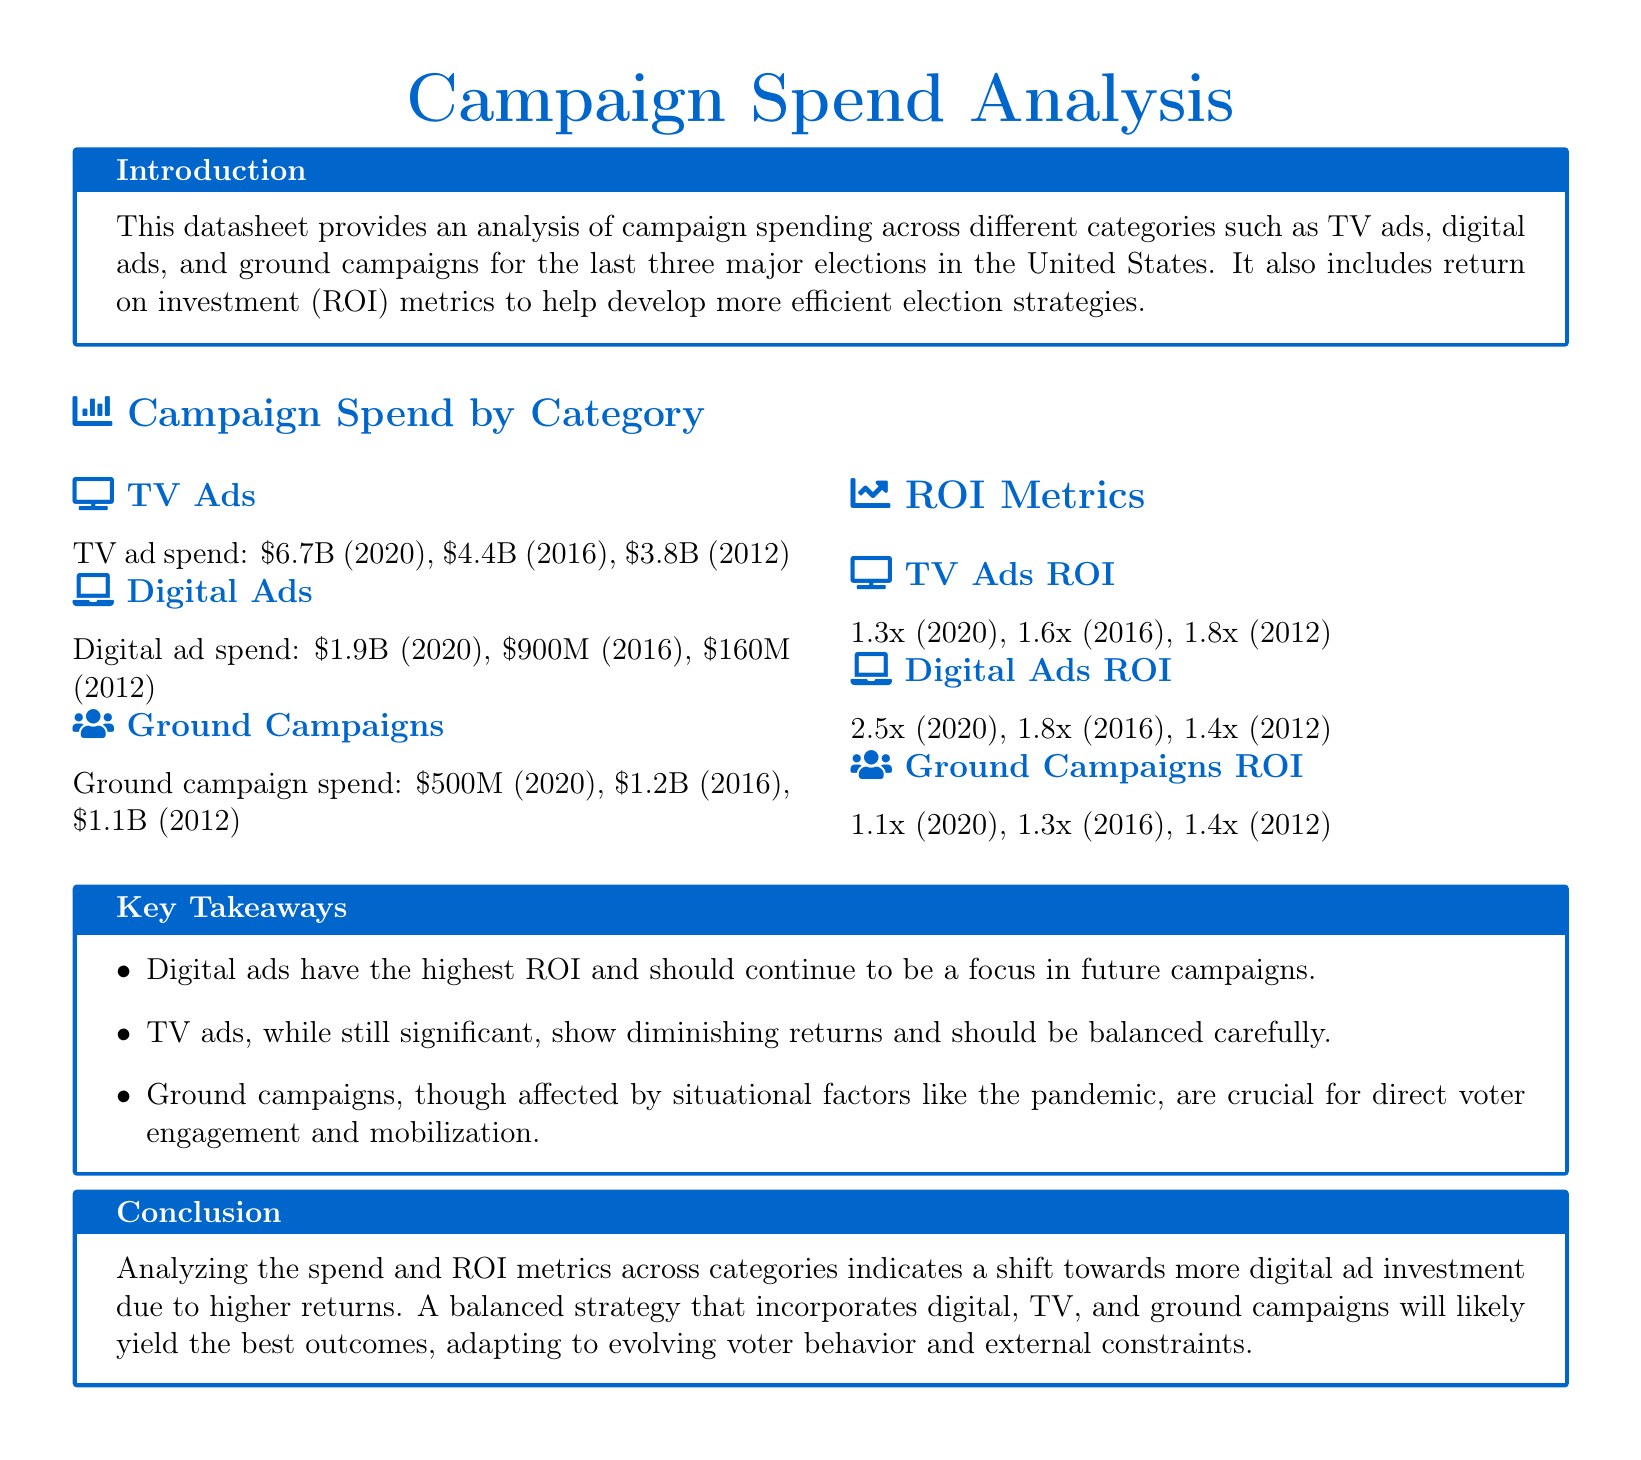what was the TV ad spend in 2020? The TV ad spend for 2020 is explicitly stated in the document.
Answer: $6.7B how much was spent on digital ads in 2012? The document provides specific digital ad spending figures for each year mentioned.
Answer: $160M what does the ROI for digital ads in 2020 represent? The ROI for digital ads in 2020 indicates the return per dollar spent based on the figures in the document.
Answer: 2.5x which campaign category had the lowest spending in 2016? The provided spending data allows for a direct comparison between categories for that year.
Answer: Ground Campaigns what trend is indicated by the ROI metrics for TV ads over the last three elections? The ROI metrics reflect a change over the years, revealing diminishing returns for TV ads as highlighted in the analysis.
Answer: Diminishing returns what was the ground campaign spend in 2016? The specific spending amounts for ground campaigns are detailed in the document for each election year.
Answer: $1.2B which category had the highest ROI in 2016? The ROI metrics allow for comparison across categories to identify which had the highest return that year.
Answer: Digital Ads what is the key takeaway regarding digital ads? The takeaways section summarizes the findings related to the efficiency of campaign strategies in the document.
Answer: Highest ROI 